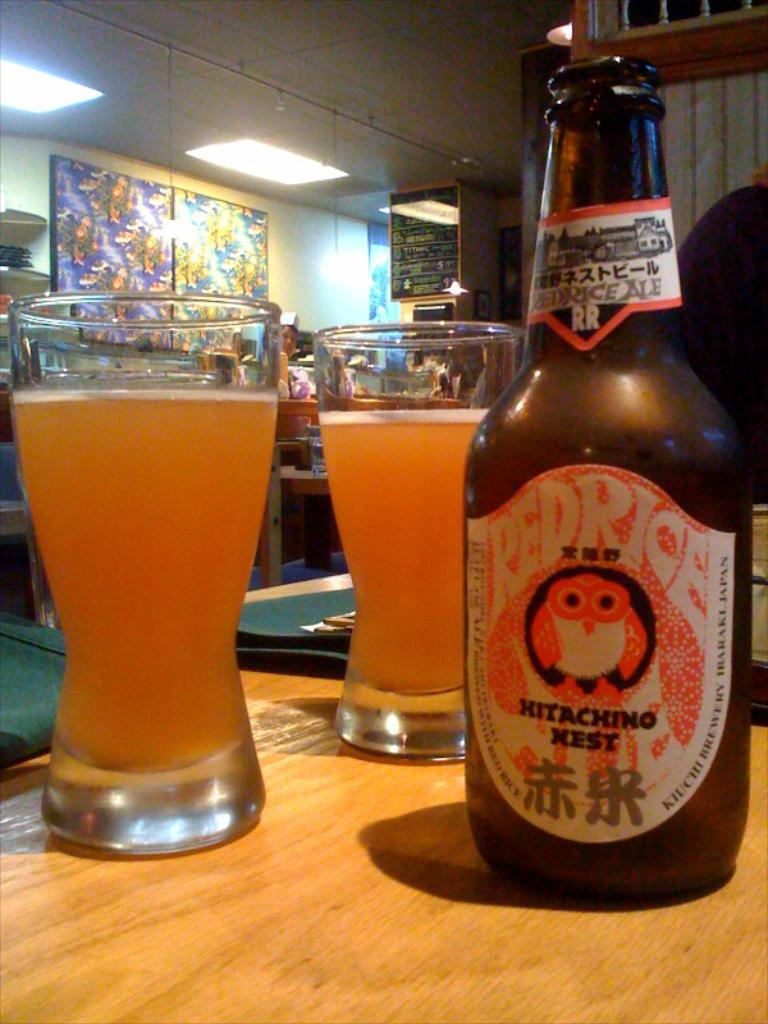Provide a one-sentence caption for the provided image. A bottle of Red Rice beer sits in two glasses on a table. 